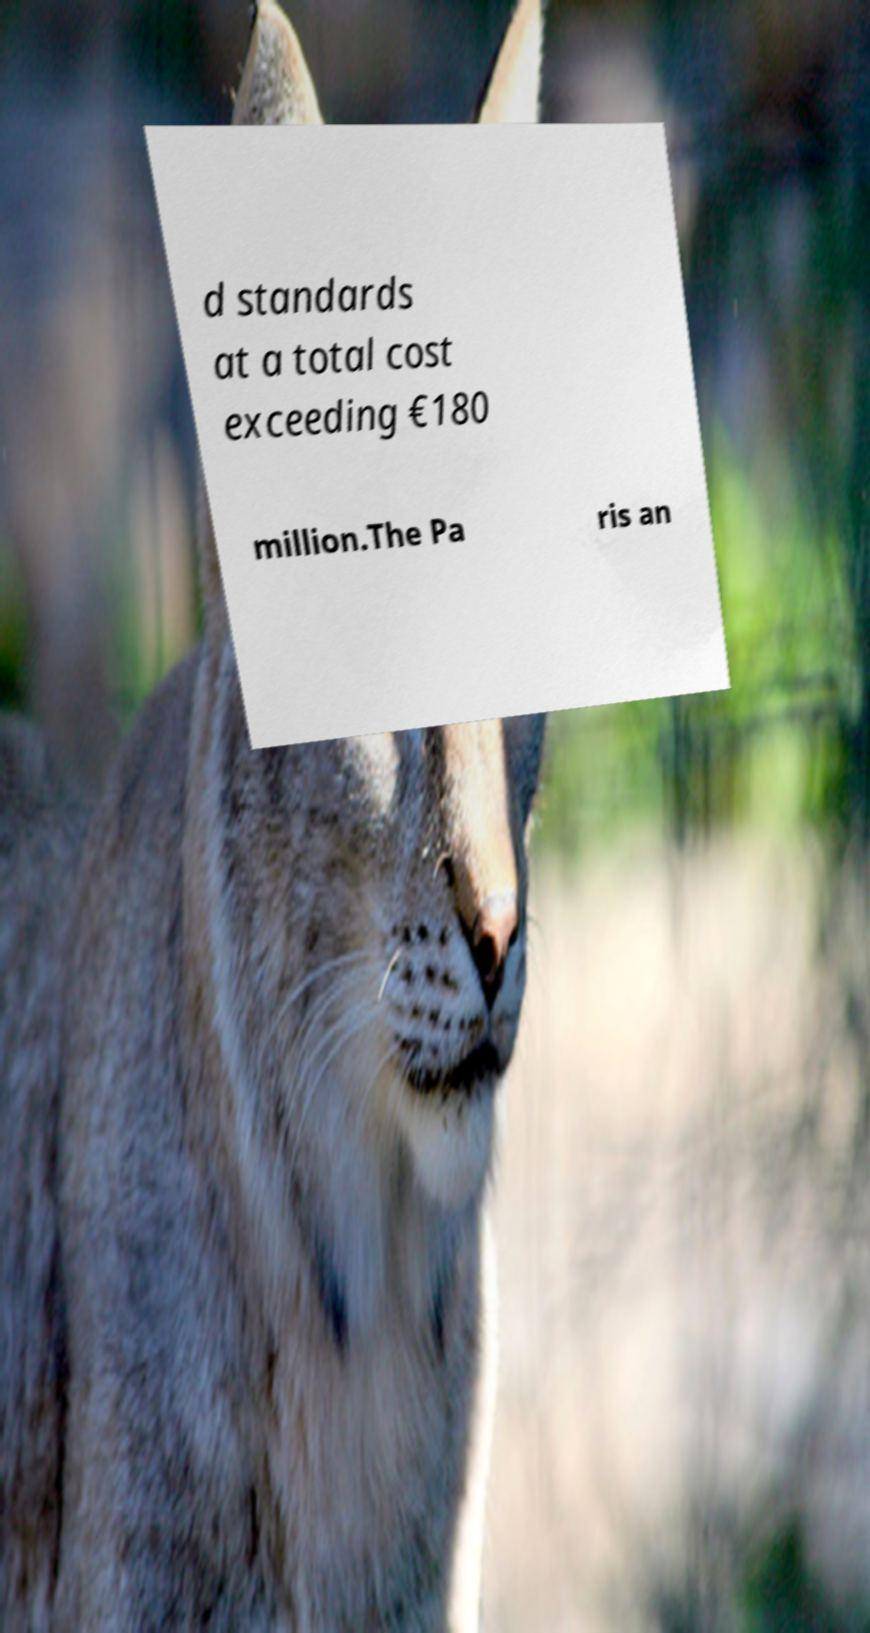What messages or text are displayed in this image? I need them in a readable, typed format. d standards at a total cost exceeding €180 million.The Pa ris an 